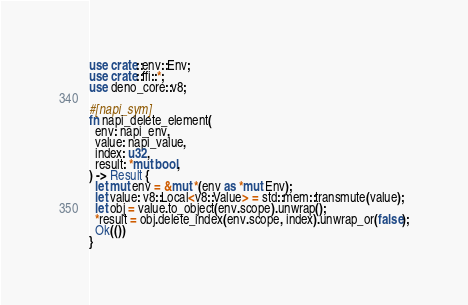<code> <loc_0><loc_0><loc_500><loc_500><_Rust_>use crate::env::Env;
use crate::ffi::*;
use deno_core::v8;

#[napi_sym]
fn napi_delete_element(
  env: napi_env,
  value: napi_value,
  index: u32,
  result: *mut bool,
) -> Result {
  let mut env = &mut *(env as *mut Env);
  let value: v8::Local<v8::Value> = std::mem::transmute(value);
  let obj = value.to_object(env.scope).unwrap();
  *result = obj.delete_index(env.scope, index).unwrap_or(false);
  Ok(())
}
</code> 